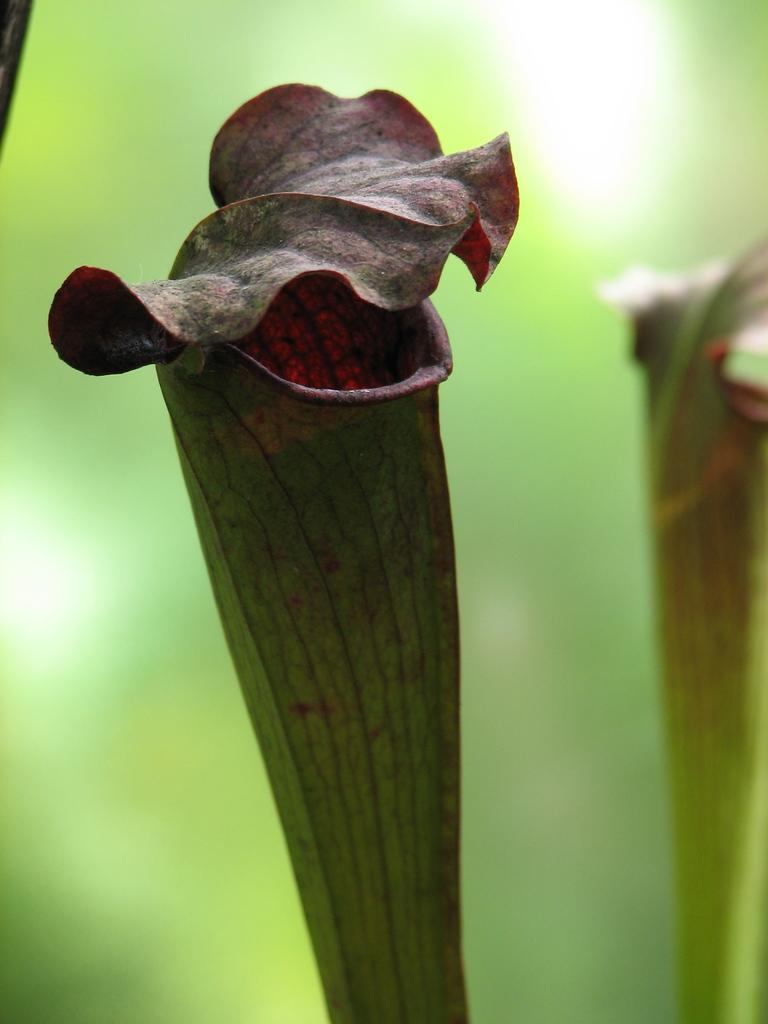How many flowers are visible in the image? There are two flowers in the image. What can be observed about the background of the image? The background of the image is blurred. Is there a visitor wearing a badge and a crown in the image? No, there is no visitor, badge, or crown present in the image. The image only features two flowers and a blurred background. 